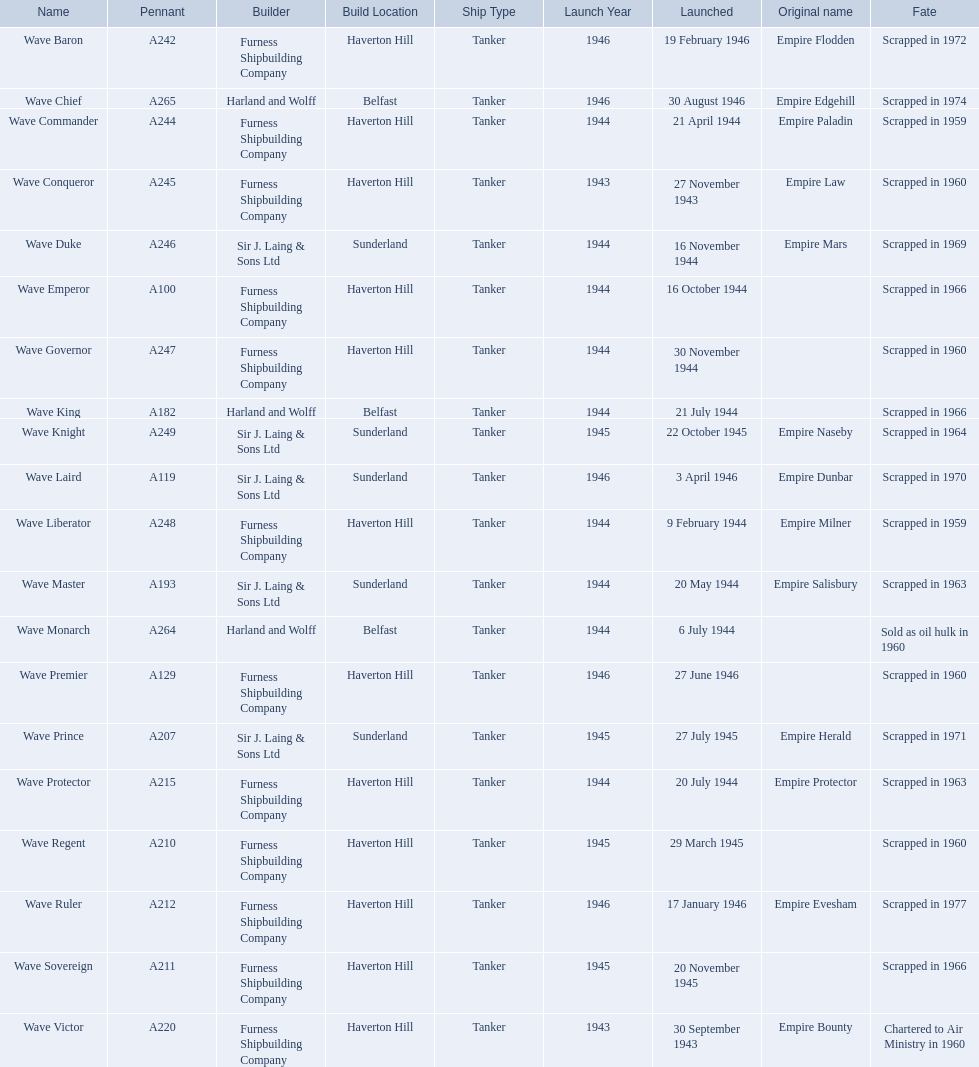What builders launched ships in november of any year? Furness Shipbuilding Company, Sir J. Laing & Sons Ltd, Furness Shipbuilding Company, Furness Shipbuilding Company. What ship builders ships had their original name's changed prior to scrapping? Furness Shipbuilding Company, Sir J. Laing & Sons Ltd. What was the name of the ship that was built in november and had its name changed prior to scrapping only 12 years after its launch? Wave Conqueror. 